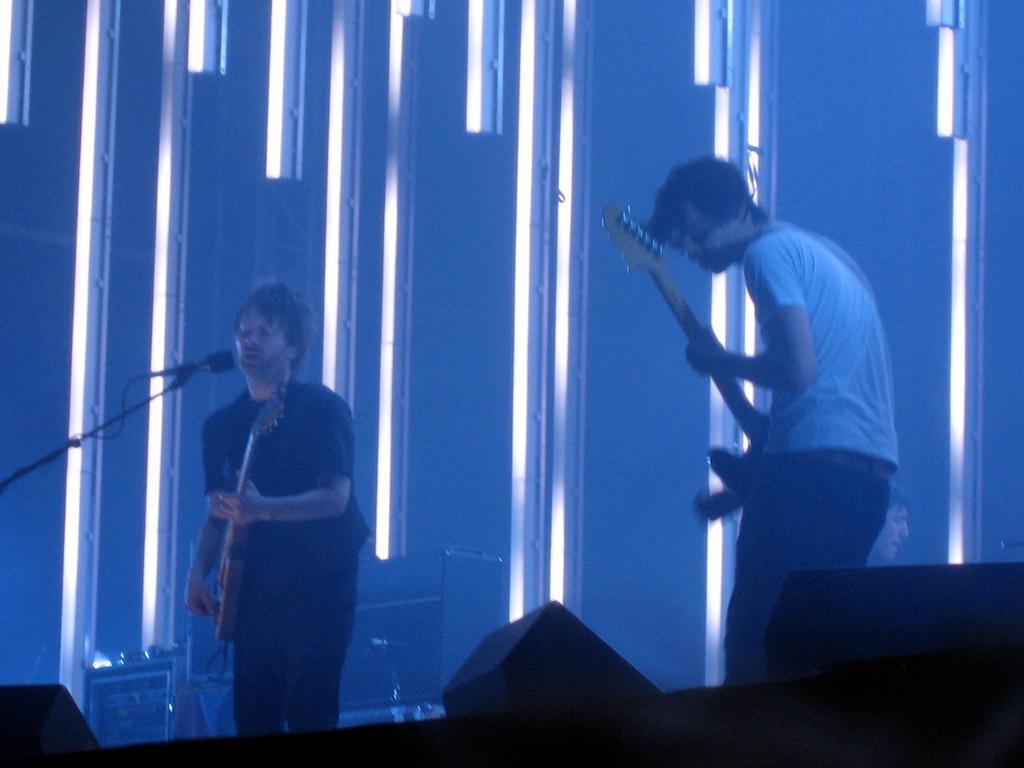Please provide a concise description of this image. Here in this picture we can see two men standing on the stage and both of them are playing guitars present in their hands and the person on the left side is singing song in the microphone present in front of him and behind them we can see other speakers and musical instruments present and in the front we can see speakers present and behind them we can see lights and iron frame present. 